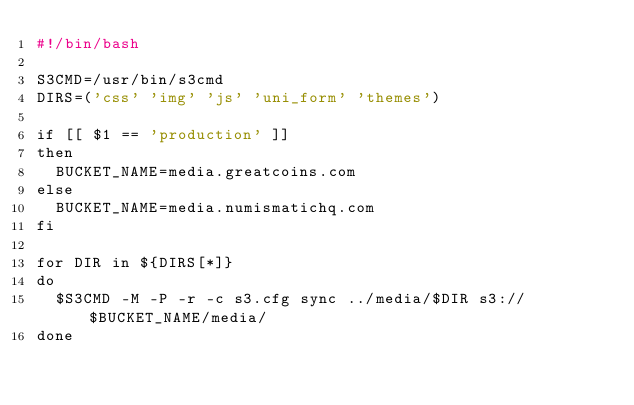<code> <loc_0><loc_0><loc_500><loc_500><_Bash_>#!/bin/bash

S3CMD=/usr/bin/s3cmd
DIRS=('css' 'img' 'js' 'uni_form' 'themes')

if [[ $1 == 'production' ]]
then
  BUCKET_NAME=media.greatcoins.com
else
  BUCKET_NAME=media.numismatichq.com
fi

for DIR in ${DIRS[*]}
do
  $S3CMD -M -P -r -c s3.cfg sync ../media/$DIR s3://$BUCKET_NAME/media/
done
</code> 